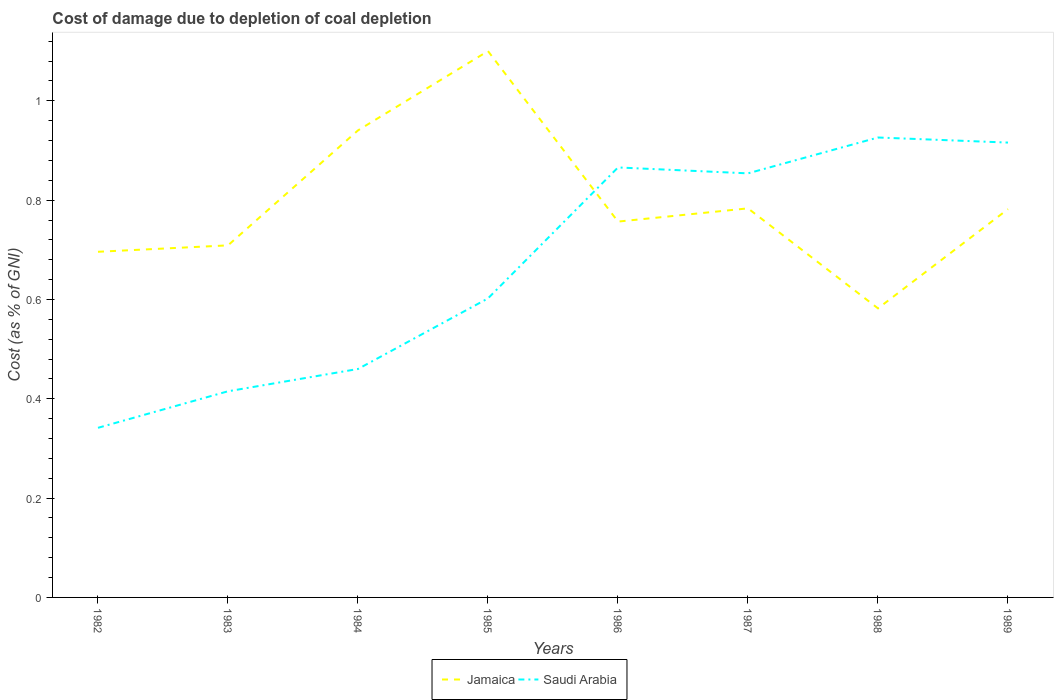How many different coloured lines are there?
Provide a succinct answer. 2. Does the line corresponding to Saudi Arabia intersect with the line corresponding to Jamaica?
Your response must be concise. Yes. Is the number of lines equal to the number of legend labels?
Provide a succinct answer. Yes. Across all years, what is the maximum cost of damage caused due to coal depletion in Jamaica?
Give a very brief answer. 0.58. What is the total cost of damage caused due to coal depletion in Saudi Arabia in the graph?
Your answer should be very brief. -0.52. What is the difference between the highest and the second highest cost of damage caused due to coal depletion in Jamaica?
Offer a terse response. 0.52. What is the difference between the highest and the lowest cost of damage caused due to coal depletion in Jamaica?
Give a very brief answer. 2. How many lines are there?
Your answer should be compact. 2. What is the difference between two consecutive major ticks on the Y-axis?
Your answer should be very brief. 0.2. Are the values on the major ticks of Y-axis written in scientific E-notation?
Ensure brevity in your answer.  No. Does the graph contain any zero values?
Ensure brevity in your answer.  No. Does the graph contain grids?
Your answer should be very brief. No. Where does the legend appear in the graph?
Offer a terse response. Bottom center. How are the legend labels stacked?
Keep it short and to the point. Horizontal. What is the title of the graph?
Your answer should be compact. Cost of damage due to depletion of coal depletion. Does "East Asia (all income levels)" appear as one of the legend labels in the graph?
Your response must be concise. No. What is the label or title of the X-axis?
Your answer should be very brief. Years. What is the label or title of the Y-axis?
Offer a very short reply. Cost (as % of GNI). What is the Cost (as % of GNI) in Jamaica in 1982?
Ensure brevity in your answer.  0.7. What is the Cost (as % of GNI) in Saudi Arabia in 1982?
Give a very brief answer. 0.34. What is the Cost (as % of GNI) of Jamaica in 1983?
Offer a very short reply. 0.71. What is the Cost (as % of GNI) of Saudi Arabia in 1983?
Your answer should be compact. 0.42. What is the Cost (as % of GNI) in Jamaica in 1984?
Give a very brief answer. 0.94. What is the Cost (as % of GNI) in Saudi Arabia in 1984?
Provide a short and direct response. 0.46. What is the Cost (as % of GNI) of Jamaica in 1985?
Provide a succinct answer. 1.1. What is the Cost (as % of GNI) of Saudi Arabia in 1985?
Your response must be concise. 0.6. What is the Cost (as % of GNI) of Jamaica in 1986?
Offer a terse response. 0.76. What is the Cost (as % of GNI) in Saudi Arabia in 1986?
Ensure brevity in your answer.  0.87. What is the Cost (as % of GNI) in Jamaica in 1987?
Ensure brevity in your answer.  0.78. What is the Cost (as % of GNI) in Saudi Arabia in 1987?
Provide a short and direct response. 0.85. What is the Cost (as % of GNI) in Jamaica in 1988?
Make the answer very short. 0.58. What is the Cost (as % of GNI) of Saudi Arabia in 1988?
Keep it short and to the point. 0.93. What is the Cost (as % of GNI) in Jamaica in 1989?
Provide a succinct answer. 0.78. What is the Cost (as % of GNI) of Saudi Arabia in 1989?
Offer a terse response. 0.92. Across all years, what is the maximum Cost (as % of GNI) in Jamaica?
Your response must be concise. 1.1. Across all years, what is the maximum Cost (as % of GNI) of Saudi Arabia?
Make the answer very short. 0.93. Across all years, what is the minimum Cost (as % of GNI) in Jamaica?
Ensure brevity in your answer.  0.58. Across all years, what is the minimum Cost (as % of GNI) in Saudi Arabia?
Offer a terse response. 0.34. What is the total Cost (as % of GNI) in Jamaica in the graph?
Offer a terse response. 6.35. What is the total Cost (as % of GNI) in Saudi Arabia in the graph?
Offer a very short reply. 5.38. What is the difference between the Cost (as % of GNI) in Jamaica in 1982 and that in 1983?
Offer a very short reply. -0.01. What is the difference between the Cost (as % of GNI) of Saudi Arabia in 1982 and that in 1983?
Give a very brief answer. -0.07. What is the difference between the Cost (as % of GNI) of Jamaica in 1982 and that in 1984?
Ensure brevity in your answer.  -0.24. What is the difference between the Cost (as % of GNI) of Saudi Arabia in 1982 and that in 1984?
Provide a short and direct response. -0.12. What is the difference between the Cost (as % of GNI) of Jamaica in 1982 and that in 1985?
Provide a succinct answer. -0.4. What is the difference between the Cost (as % of GNI) of Saudi Arabia in 1982 and that in 1985?
Ensure brevity in your answer.  -0.26. What is the difference between the Cost (as % of GNI) of Jamaica in 1982 and that in 1986?
Offer a terse response. -0.06. What is the difference between the Cost (as % of GNI) in Saudi Arabia in 1982 and that in 1986?
Provide a short and direct response. -0.52. What is the difference between the Cost (as % of GNI) in Jamaica in 1982 and that in 1987?
Make the answer very short. -0.09. What is the difference between the Cost (as % of GNI) in Saudi Arabia in 1982 and that in 1987?
Your answer should be compact. -0.51. What is the difference between the Cost (as % of GNI) of Jamaica in 1982 and that in 1988?
Offer a terse response. 0.11. What is the difference between the Cost (as % of GNI) of Saudi Arabia in 1982 and that in 1988?
Your answer should be compact. -0.58. What is the difference between the Cost (as % of GNI) in Jamaica in 1982 and that in 1989?
Provide a short and direct response. -0.09. What is the difference between the Cost (as % of GNI) of Saudi Arabia in 1982 and that in 1989?
Offer a terse response. -0.57. What is the difference between the Cost (as % of GNI) of Jamaica in 1983 and that in 1984?
Your response must be concise. -0.23. What is the difference between the Cost (as % of GNI) in Saudi Arabia in 1983 and that in 1984?
Make the answer very short. -0.04. What is the difference between the Cost (as % of GNI) of Jamaica in 1983 and that in 1985?
Your answer should be compact. -0.39. What is the difference between the Cost (as % of GNI) in Saudi Arabia in 1983 and that in 1985?
Your answer should be very brief. -0.19. What is the difference between the Cost (as % of GNI) of Jamaica in 1983 and that in 1986?
Offer a terse response. -0.05. What is the difference between the Cost (as % of GNI) of Saudi Arabia in 1983 and that in 1986?
Offer a very short reply. -0.45. What is the difference between the Cost (as % of GNI) in Jamaica in 1983 and that in 1987?
Offer a terse response. -0.07. What is the difference between the Cost (as % of GNI) in Saudi Arabia in 1983 and that in 1987?
Provide a short and direct response. -0.44. What is the difference between the Cost (as % of GNI) in Jamaica in 1983 and that in 1988?
Provide a short and direct response. 0.13. What is the difference between the Cost (as % of GNI) of Saudi Arabia in 1983 and that in 1988?
Give a very brief answer. -0.51. What is the difference between the Cost (as % of GNI) in Jamaica in 1983 and that in 1989?
Offer a very short reply. -0.07. What is the difference between the Cost (as % of GNI) in Saudi Arabia in 1983 and that in 1989?
Ensure brevity in your answer.  -0.5. What is the difference between the Cost (as % of GNI) in Jamaica in 1984 and that in 1985?
Provide a succinct answer. -0.16. What is the difference between the Cost (as % of GNI) in Saudi Arabia in 1984 and that in 1985?
Provide a short and direct response. -0.14. What is the difference between the Cost (as % of GNI) of Jamaica in 1984 and that in 1986?
Offer a very short reply. 0.18. What is the difference between the Cost (as % of GNI) of Saudi Arabia in 1984 and that in 1986?
Keep it short and to the point. -0.41. What is the difference between the Cost (as % of GNI) in Jamaica in 1984 and that in 1987?
Offer a very short reply. 0.16. What is the difference between the Cost (as % of GNI) of Saudi Arabia in 1984 and that in 1987?
Provide a succinct answer. -0.39. What is the difference between the Cost (as % of GNI) of Jamaica in 1984 and that in 1988?
Your answer should be very brief. 0.36. What is the difference between the Cost (as % of GNI) of Saudi Arabia in 1984 and that in 1988?
Make the answer very short. -0.47. What is the difference between the Cost (as % of GNI) of Jamaica in 1984 and that in 1989?
Make the answer very short. 0.16. What is the difference between the Cost (as % of GNI) in Saudi Arabia in 1984 and that in 1989?
Your answer should be very brief. -0.46. What is the difference between the Cost (as % of GNI) of Jamaica in 1985 and that in 1986?
Offer a very short reply. 0.34. What is the difference between the Cost (as % of GNI) of Saudi Arabia in 1985 and that in 1986?
Your answer should be very brief. -0.26. What is the difference between the Cost (as % of GNI) in Jamaica in 1985 and that in 1987?
Offer a terse response. 0.32. What is the difference between the Cost (as % of GNI) of Saudi Arabia in 1985 and that in 1987?
Offer a very short reply. -0.25. What is the difference between the Cost (as % of GNI) of Jamaica in 1985 and that in 1988?
Your answer should be very brief. 0.52. What is the difference between the Cost (as % of GNI) of Saudi Arabia in 1985 and that in 1988?
Give a very brief answer. -0.32. What is the difference between the Cost (as % of GNI) in Jamaica in 1985 and that in 1989?
Provide a succinct answer. 0.32. What is the difference between the Cost (as % of GNI) of Saudi Arabia in 1985 and that in 1989?
Your answer should be compact. -0.31. What is the difference between the Cost (as % of GNI) of Jamaica in 1986 and that in 1987?
Give a very brief answer. -0.03. What is the difference between the Cost (as % of GNI) of Saudi Arabia in 1986 and that in 1987?
Your answer should be very brief. 0.01. What is the difference between the Cost (as % of GNI) of Jamaica in 1986 and that in 1988?
Offer a very short reply. 0.17. What is the difference between the Cost (as % of GNI) in Saudi Arabia in 1986 and that in 1988?
Ensure brevity in your answer.  -0.06. What is the difference between the Cost (as % of GNI) of Jamaica in 1986 and that in 1989?
Provide a succinct answer. -0.03. What is the difference between the Cost (as % of GNI) of Saudi Arabia in 1986 and that in 1989?
Give a very brief answer. -0.05. What is the difference between the Cost (as % of GNI) in Jamaica in 1987 and that in 1988?
Your answer should be very brief. 0.2. What is the difference between the Cost (as % of GNI) in Saudi Arabia in 1987 and that in 1988?
Keep it short and to the point. -0.07. What is the difference between the Cost (as % of GNI) of Jamaica in 1987 and that in 1989?
Your answer should be very brief. 0. What is the difference between the Cost (as % of GNI) in Saudi Arabia in 1987 and that in 1989?
Give a very brief answer. -0.06. What is the difference between the Cost (as % of GNI) of Jamaica in 1988 and that in 1989?
Give a very brief answer. -0.2. What is the difference between the Cost (as % of GNI) of Saudi Arabia in 1988 and that in 1989?
Offer a very short reply. 0.01. What is the difference between the Cost (as % of GNI) of Jamaica in 1982 and the Cost (as % of GNI) of Saudi Arabia in 1983?
Offer a terse response. 0.28. What is the difference between the Cost (as % of GNI) in Jamaica in 1982 and the Cost (as % of GNI) in Saudi Arabia in 1984?
Give a very brief answer. 0.24. What is the difference between the Cost (as % of GNI) in Jamaica in 1982 and the Cost (as % of GNI) in Saudi Arabia in 1985?
Keep it short and to the point. 0.09. What is the difference between the Cost (as % of GNI) of Jamaica in 1982 and the Cost (as % of GNI) of Saudi Arabia in 1986?
Your response must be concise. -0.17. What is the difference between the Cost (as % of GNI) of Jamaica in 1982 and the Cost (as % of GNI) of Saudi Arabia in 1987?
Keep it short and to the point. -0.16. What is the difference between the Cost (as % of GNI) in Jamaica in 1982 and the Cost (as % of GNI) in Saudi Arabia in 1988?
Keep it short and to the point. -0.23. What is the difference between the Cost (as % of GNI) of Jamaica in 1982 and the Cost (as % of GNI) of Saudi Arabia in 1989?
Make the answer very short. -0.22. What is the difference between the Cost (as % of GNI) of Jamaica in 1983 and the Cost (as % of GNI) of Saudi Arabia in 1984?
Provide a succinct answer. 0.25. What is the difference between the Cost (as % of GNI) of Jamaica in 1983 and the Cost (as % of GNI) of Saudi Arabia in 1985?
Provide a succinct answer. 0.11. What is the difference between the Cost (as % of GNI) in Jamaica in 1983 and the Cost (as % of GNI) in Saudi Arabia in 1986?
Your answer should be very brief. -0.16. What is the difference between the Cost (as % of GNI) of Jamaica in 1983 and the Cost (as % of GNI) of Saudi Arabia in 1987?
Your answer should be very brief. -0.14. What is the difference between the Cost (as % of GNI) of Jamaica in 1983 and the Cost (as % of GNI) of Saudi Arabia in 1988?
Provide a short and direct response. -0.22. What is the difference between the Cost (as % of GNI) of Jamaica in 1983 and the Cost (as % of GNI) of Saudi Arabia in 1989?
Provide a short and direct response. -0.21. What is the difference between the Cost (as % of GNI) in Jamaica in 1984 and the Cost (as % of GNI) in Saudi Arabia in 1985?
Offer a very short reply. 0.34. What is the difference between the Cost (as % of GNI) of Jamaica in 1984 and the Cost (as % of GNI) of Saudi Arabia in 1986?
Keep it short and to the point. 0.07. What is the difference between the Cost (as % of GNI) of Jamaica in 1984 and the Cost (as % of GNI) of Saudi Arabia in 1987?
Make the answer very short. 0.09. What is the difference between the Cost (as % of GNI) of Jamaica in 1984 and the Cost (as % of GNI) of Saudi Arabia in 1988?
Offer a very short reply. 0.01. What is the difference between the Cost (as % of GNI) in Jamaica in 1984 and the Cost (as % of GNI) in Saudi Arabia in 1989?
Provide a short and direct response. 0.02. What is the difference between the Cost (as % of GNI) in Jamaica in 1985 and the Cost (as % of GNI) in Saudi Arabia in 1986?
Your answer should be compact. 0.23. What is the difference between the Cost (as % of GNI) in Jamaica in 1985 and the Cost (as % of GNI) in Saudi Arabia in 1987?
Ensure brevity in your answer.  0.25. What is the difference between the Cost (as % of GNI) of Jamaica in 1985 and the Cost (as % of GNI) of Saudi Arabia in 1988?
Keep it short and to the point. 0.17. What is the difference between the Cost (as % of GNI) in Jamaica in 1985 and the Cost (as % of GNI) in Saudi Arabia in 1989?
Keep it short and to the point. 0.18. What is the difference between the Cost (as % of GNI) in Jamaica in 1986 and the Cost (as % of GNI) in Saudi Arabia in 1987?
Provide a short and direct response. -0.1. What is the difference between the Cost (as % of GNI) in Jamaica in 1986 and the Cost (as % of GNI) in Saudi Arabia in 1988?
Keep it short and to the point. -0.17. What is the difference between the Cost (as % of GNI) of Jamaica in 1986 and the Cost (as % of GNI) of Saudi Arabia in 1989?
Your answer should be very brief. -0.16. What is the difference between the Cost (as % of GNI) of Jamaica in 1987 and the Cost (as % of GNI) of Saudi Arabia in 1988?
Ensure brevity in your answer.  -0.14. What is the difference between the Cost (as % of GNI) in Jamaica in 1987 and the Cost (as % of GNI) in Saudi Arabia in 1989?
Provide a short and direct response. -0.13. What is the difference between the Cost (as % of GNI) of Jamaica in 1988 and the Cost (as % of GNI) of Saudi Arabia in 1989?
Your answer should be compact. -0.33. What is the average Cost (as % of GNI) in Jamaica per year?
Ensure brevity in your answer.  0.79. What is the average Cost (as % of GNI) of Saudi Arabia per year?
Your answer should be very brief. 0.67. In the year 1982, what is the difference between the Cost (as % of GNI) of Jamaica and Cost (as % of GNI) of Saudi Arabia?
Offer a very short reply. 0.35. In the year 1983, what is the difference between the Cost (as % of GNI) in Jamaica and Cost (as % of GNI) in Saudi Arabia?
Offer a very short reply. 0.29. In the year 1984, what is the difference between the Cost (as % of GNI) in Jamaica and Cost (as % of GNI) in Saudi Arabia?
Keep it short and to the point. 0.48. In the year 1985, what is the difference between the Cost (as % of GNI) in Jamaica and Cost (as % of GNI) in Saudi Arabia?
Your answer should be very brief. 0.5. In the year 1986, what is the difference between the Cost (as % of GNI) of Jamaica and Cost (as % of GNI) of Saudi Arabia?
Your answer should be very brief. -0.11. In the year 1987, what is the difference between the Cost (as % of GNI) of Jamaica and Cost (as % of GNI) of Saudi Arabia?
Provide a succinct answer. -0.07. In the year 1988, what is the difference between the Cost (as % of GNI) of Jamaica and Cost (as % of GNI) of Saudi Arabia?
Provide a short and direct response. -0.34. In the year 1989, what is the difference between the Cost (as % of GNI) of Jamaica and Cost (as % of GNI) of Saudi Arabia?
Provide a succinct answer. -0.13. What is the ratio of the Cost (as % of GNI) of Jamaica in 1982 to that in 1983?
Your answer should be compact. 0.98. What is the ratio of the Cost (as % of GNI) in Saudi Arabia in 1982 to that in 1983?
Keep it short and to the point. 0.82. What is the ratio of the Cost (as % of GNI) of Jamaica in 1982 to that in 1984?
Your response must be concise. 0.74. What is the ratio of the Cost (as % of GNI) in Saudi Arabia in 1982 to that in 1984?
Your answer should be very brief. 0.74. What is the ratio of the Cost (as % of GNI) of Jamaica in 1982 to that in 1985?
Ensure brevity in your answer.  0.63. What is the ratio of the Cost (as % of GNI) in Saudi Arabia in 1982 to that in 1985?
Provide a succinct answer. 0.57. What is the ratio of the Cost (as % of GNI) in Jamaica in 1982 to that in 1986?
Keep it short and to the point. 0.92. What is the ratio of the Cost (as % of GNI) of Saudi Arabia in 1982 to that in 1986?
Your response must be concise. 0.39. What is the ratio of the Cost (as % of GNI) of Jamaica in 1982 to that in 1987?
Keep it short and to the point. 0.89. What is the ratio of the Cost (as % of GNI) in Saudi Arabia in 1982 to that in 1987?
Your answer should be very brief. 0.4. What is the ratio of the Cost (as % of GNI) in Jamaica in 1982 to that in 1988?
Keep it short and to the point. 1.2. What is the ratio of the Cost (as % of GNI) in Saudi Arabia in 1982 to that in 1988?
Provide a short and direct response. 0.37. What is the ratio of the Cost (as % of GNI) of Jamaica in 1982 to that in 1989?
Your answer should be compact. 0.89. What is the ratio of the Cost (as % of GNI) of Saudi Arabia in 1982 to that in 1989?
Give a very brief answer. 0.37. What is the ratio of the Cost (as % of GNI) in Jamaica in 1983 to that in 1984?
Keep it short and to the point. 0.75. What is the ratio of the Cost (as % of GNI) of Saudi Arabia in 1983 to that in 1984?
Offer a very short reply. 0.9. What is the ratio of the Cost (as % of GNI) in Jamaica in 1983 to that in 1985?
Keep it short and to the point. 0.64. What is the ratio of the Cost (as % of GNI) of Saudi Arabia in 1983 to that in 1985?
Your response must be concise. 0.69. What is the ratio of the Cost (as % of GNI) of Jamaica in 1983 to that in 1986?
Offer a terse response. 0.94. What is the ratio of the Cost (as % of GNI) in Saudi Arabia in 1983 to that in 1986?
Your response must be concise. 0.48. What is the ratio of the Cost (as % of GNI) in Jamaica in 1983 to that in 1987?
Make the answer very short. 0.9. What is the ratio of the Cost (as % of GNI) in Saudi Arabia in 1983 to that in 1987?
Your response must be concise. 0.49. What is the ratio of the Cost (as % of GNI) of Jamaica in 1983 to that in 1988?
Your response must be concise. 1.22. What is the ratio of the Cost (as % of GNI) of Saudi Arabia in 1983 to that in 1988?
Make the answer very short. 0.45. What is the ratio of the Cost (as % of GNI) of Jamaica in 1983 to that in 1989?
Ensure brevity in your answer.  0.91. What is the ratio of the Cost (as % of GNI) of Saudi Arabia in 1983 to that in 1989?
Your answer should be very brief. 0.45. What is the ratio of the Cost (as % of GNI) in Jamaica in 1984 to that in 1985?
Your response must be concise. 0.85. What is the ratio of the Cost (as % of GNI) of Saudi Arabia in 1984 to that in 1985?
Your answer should be very brief. 0.76. What is the ratio of the Cost (as % of GNI) of Jamaica in 1984 to that in 1986?
Your answer should be compact. 1.24. What is the ratio of the Cost (as % of GNI) in Saudi Arabia in 1984 to that in 1986?
Your answer should be compact. 0.53. What is the ratio of the Cost (as % of GNI) of Jamaica in 1984 to that in 1987?
Your response must be concise. 1.2. What is the ratio of the Cost (as % of GNI) in Saudi Arabia in 1984 to that in 1987?
Offer a terse response. 0.54. What is the ratio of the Cost (as % of GNI) of Jamaica in 1984 to that in 1988?
Provide a succinct answer. 1.62. What is the ratio of the Cost (as % of GNI) of Saudi Arabia in 1984 to that in 1988?
Provide a succinct answer. 0.5. What is the ratio of the Cost (as % of GNI) in Jamaica in 1984 to that in 1989?
Provide a short and direct response. 1.2. What is the ratio of the Cost (as % of GNI) of Saudi Arabia in 1984 to that in 1989?
Provide a succinct answer. 0.5. What is the ratio of the Cost (as % of GNI) in Jamaica in 1985 to that in 1986?
Provide a short and direct response. 1.45. What is the ratio of the Cost (as % of GNI) in Saudi Arabia in 1985 to that in 1986?
Your answer should be compact. 0.7. What is the ratio of the Cost (as % of GNI) of Jamaica in 1985 to that in 1987?
Your response must be concise. 1.4. What is the ratio of the Cost (as % of GNI) in Saudi Arabia in 1985 to that in 1987?
Provide a succinct answer. 0.71. What is the ratio of the Cost (as % of GNI) in Jamaica in 1985 to that in 1988?
Provide a succinct answer. 1.89. What is the ratio of the Cost (as % of GNI) in Saudi Arabia in 1985 to that in 1988?
Your answer should be very brief. 0.65. What is the ratio of the Cost (as % of GNI) in Jamaica in 1985 to that in 1989?
Provide a succinct answer. 1.41. What is the ratio of the Cost (as % of GNI) of Saudi Arabia in 1985 to that in 1989?
Your answer should be compact. 0.66. What is the ratio of the Cost (as % of GNI) of Saudi Arabia in 1986 to that in 1987?
Your answer should be compact. 1.01. What is the ratio of the Cost (as % of GNI) of Jamaica in 1986 to that in 1988?
Keep it short and to the point. 1.3. What is the ratio of the Cost (as % of GNI) of Saudi Arabia in 1986 to that in 1988?
Your answer should be compact. 0.93. What is the ratio of the Cost (as % of GNI) of Jamaica in 1986 to that in 1989?
Offer a terse response. 0.97. What is the ratio of the Cost (as % of GNI) in Saudi Arabia in 1986 to that in 1989?
Your answer should be compact. 0.95. What is the ratio of the Cost (as % of GNI) of Jamaica in 1987 to that in 1988?
Your answer should be compact. 1.35. What is the ratio of the Cost (as % of GNI) in Saudi Arabia in 1987 to that in 1988?
Offer a very short reply. 0.92. What is the ratio of the Cost (as % of GNI) of Jamaica in 1987 to that in 1989?
Offer a very short reply. 1. What is the ratio of the Cost (as % of GNI) of Saudi Arabia in 1987 to that in 1989?
Provide a succinct answer. 0.93. What is the ratio of the Cost (as % of GNI) of Jamaica in 1988 to that in 1989?
Your answer should be very brief. 0.74. What is the ratio of the Cost (as % of GNI) of Saudi Arabia in 1988 to that in 1989?
Your answer should be compact. 1.01. What is the difference between the highest and the second highest Cost (as % of GNI) in Jamaica?
Make the answer very short. 0.16. What is the difference between the highest and the second highest Cost (as % of GNI) in Saudi Arabia?
Your response must be concise. 0.01. What is the difference between the highest and the lowest Cost (as % of GNI) in Jamaica?
Your answer should be very brief. 0.52. What is the difference between the highest and the lowest Cost (as % of GNI) of Saudi Arabia?
Keep it short and to the point. 0.58. 